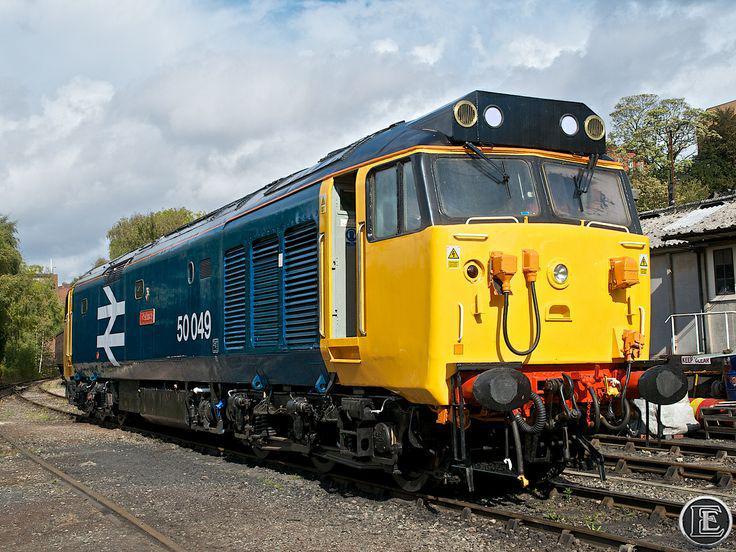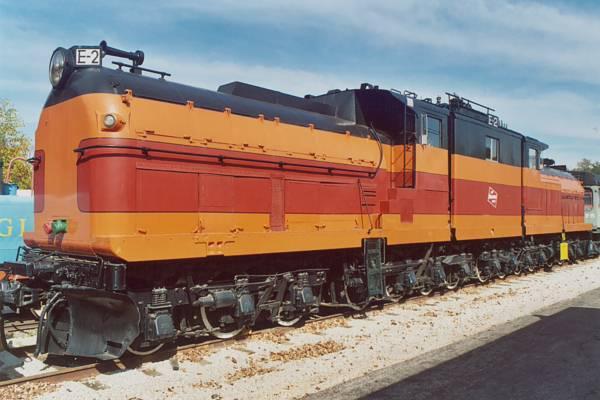The first image is the image on the left, the second image is the image on the right. Given the left and right images, does the statement "In one image, an orange and yellow locomotive has steps and white hand rails leading to a small yellow platform." hold true? Answer yes or no. No. The first image is the image on the left, the second image is the image on the right. For the images displayed, is the sentence "The trains in the left and right images appear to be headed toward each other, so they would collide." factually correct? Answer yes or no. Yes. 